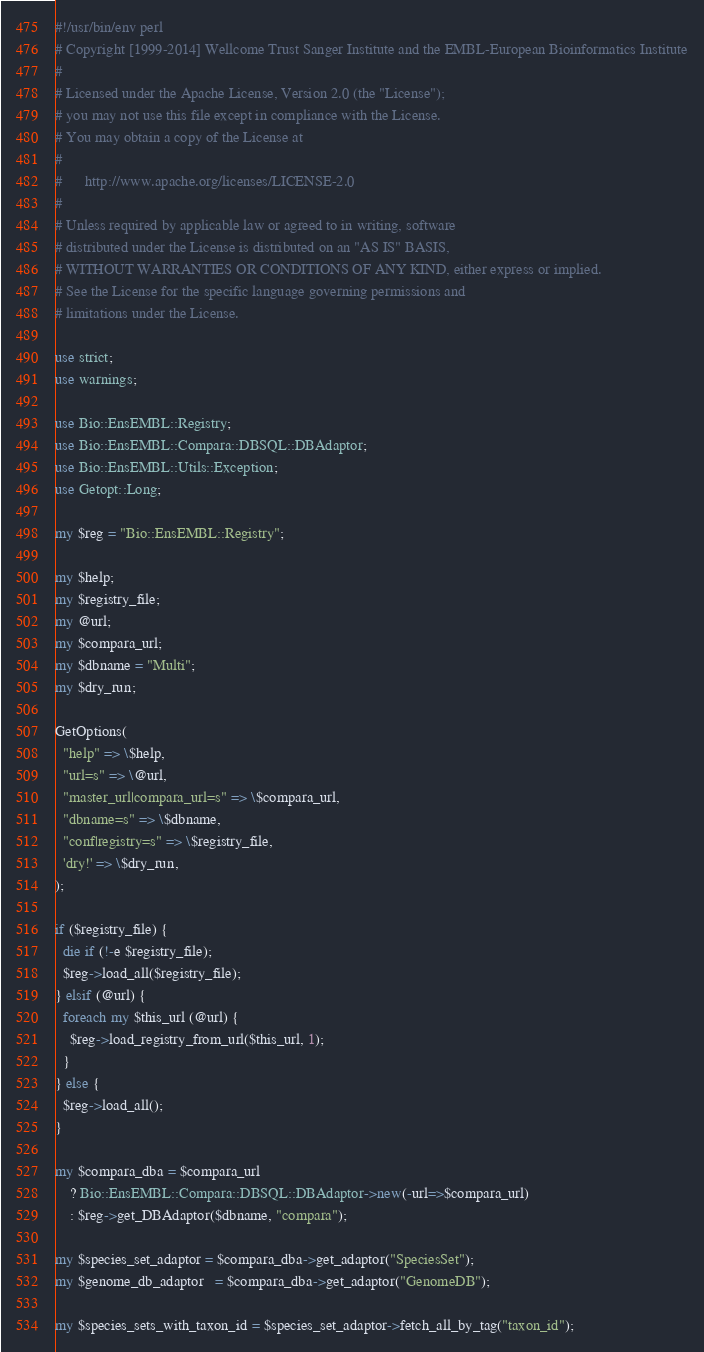<code> <loc_0><loc_0><loc_500><loc_500><_Perl_>#!/usr/bin/env perl
# Copyright [1999-2014] Wellcome Trust Sanger Institute and the EMBL-European Bioinformatics Institute
# 
# Licensed under the Apache License, Version 2.0 (the "License");
# you may not use this file except in compliance with the License.
# You may obtain a copy of the License at
# 
#      http://www.apache.org/licenses/LICENSE-2.0
# 
# Unless required by applicable law or agreed to in writing, software
# distributed under the License is distributed on an "AS IS" BASIS,
# WITHOUT WARRANTIES OR CONDITIONS OF ANY KIND, either express or implied.
# See the License for the specific language governing permissions and
# limitations under the License.

use strict;
use warnings;

use Bio::EnsEMBL::Registry;
use Bio::EnsEMBL::Compara::DBSQL::DBAdaptor;
use Bio::EnsEMBL::Utils::Exception;
use Getopt::Long;

my $reg = "Bio::EnsEMBL::Registry";

my $help;
my $registry_file;
my @url;
my $compara_url;
my $dbname = "Multi";
my $dry_run;

GetOptions(
  "help" => \$help,
  "url=s" => \@url,
  "master_url|compara_url=s" => \$compara_url,
  "dbname=s" => \$dbname,
  "conf|registry=s" => \$registry_file,
  'dry!' => \$dry_run,
);

if ($registry_file) {
  die if (!-e $registry_file);
  $reg->load_all($registry_file);
} elsif (@url) {
  foreach my $this_url (@url) {
    $reg->load_registry_from_url($this_url, 1);
  }
} else {
  $reg->load_all();
}

my $compara_dba = $compara_url
    ? Bio::EnsEMBL::Compara::DBSQL::DBAdaptor->new(-url=>$compara_url)
    : $reg->get_DBAdaptor($dbname, "compara");

my $species_set_adaptor = $compara_dba->get_adaptor("SpeciesSet");
my $genome_db_adaptor   = $compara_dba->get_adaptor("GenomeDB");

my $species_sets_with_taxon_id = $species_set_adaptor->fetch_all_by_tag("taxon_id");</code> 